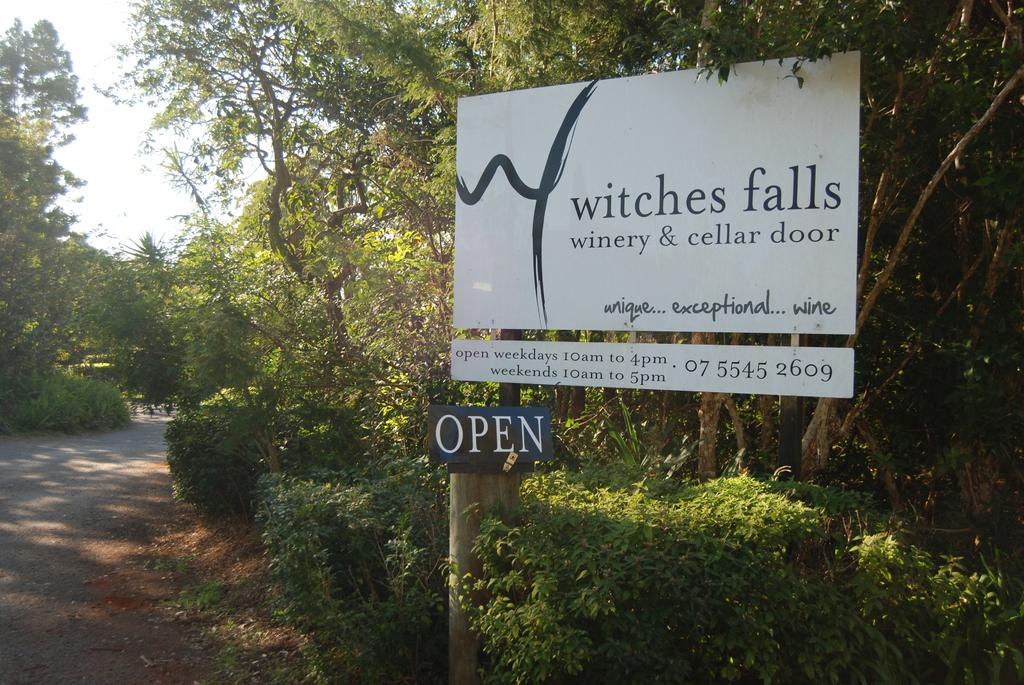What can be seen in the foreground of the picture? In the foreground of the picture, there are plants, trees, a hoarding, and a plate. What is present on the left side of the picture? On the left side of the picture, there are trees and a path. What is the weather like in the image? The weather is sunny in the image. How does the shade of the trees help to measure the distance between the plate and the hoarding? The image does not show any shade from the trees, nor does it mention measuring the distance between the plate and the hoarding. Additionally, trees do not have the ability to provide shade for measuring distances. 